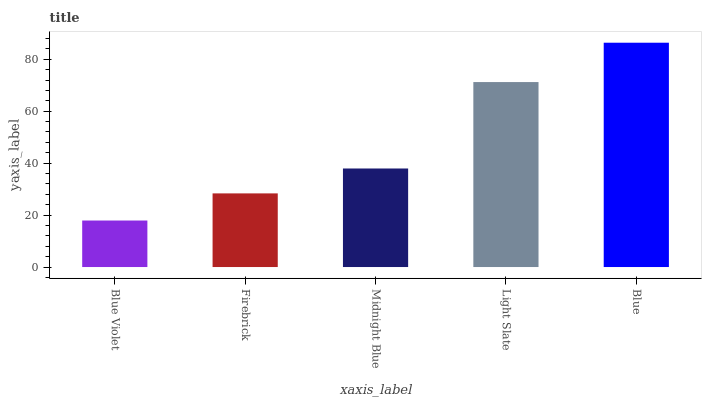Is Blue Violet the minimum?
Answer yes or no. Yes. Is Blue the maximum?
Answer yes or no. Yes. Is Firebrick the minimum?
Answer yes or no. No. Is Firebrick the maximum?
Answer yes or no. No. Is Firebrick greater than Blue Violet?
Answer yes or no. Yes. Is Blue Violet less than Firebrick?
Answer yes or no. Yes. Is Blue Violet greater than Firebrick?
Answer yes or no. No. Is Firebrick less than Blue Violet?
Answer yes or no. No. Is Midnight Blue the high median?
Answer yes or no. Yes. Is Midnight Blue the low median?
Answer yes or no. Yes. Is Firebrick the high median?
Answer yes or no. No. Is Light Slate the low median?
Answer yes or no. No. 